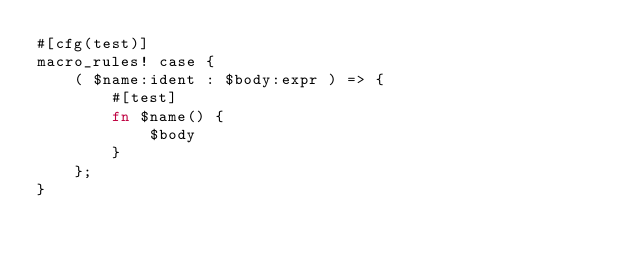<code> <loc_0><loc_0><loc_500><loc_500><_Rust_>#[cfg(test)]
macro_rules! case {
    ( $name:ident : $body:expr ) => {
        #[test]
        fn $name() {
            $body
        }
    };
}
</code> 